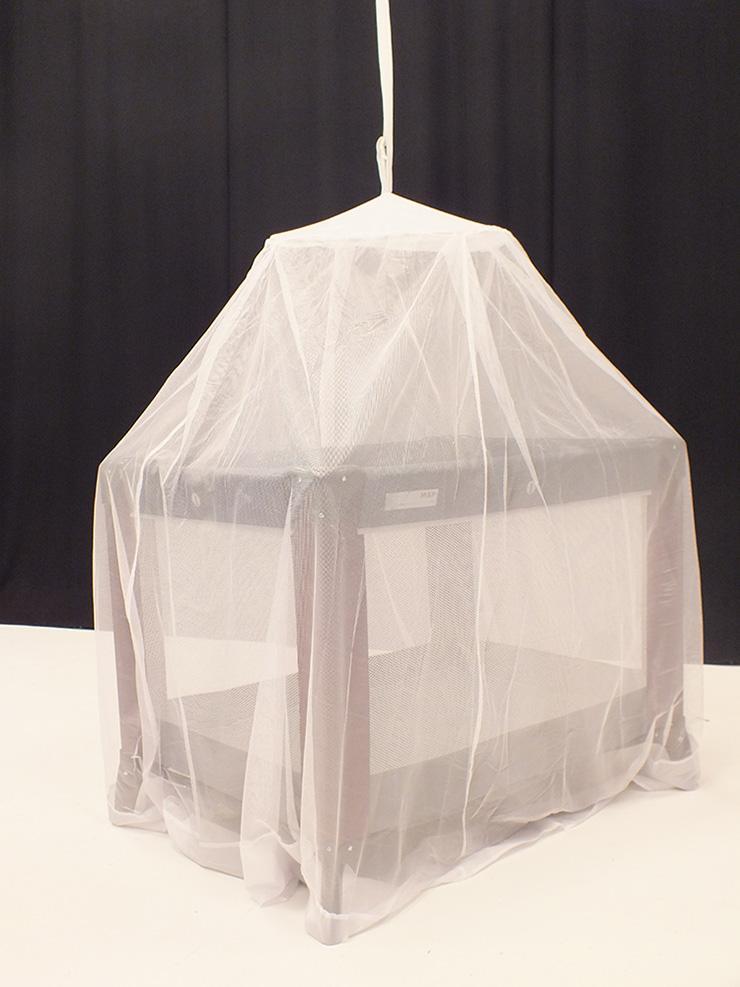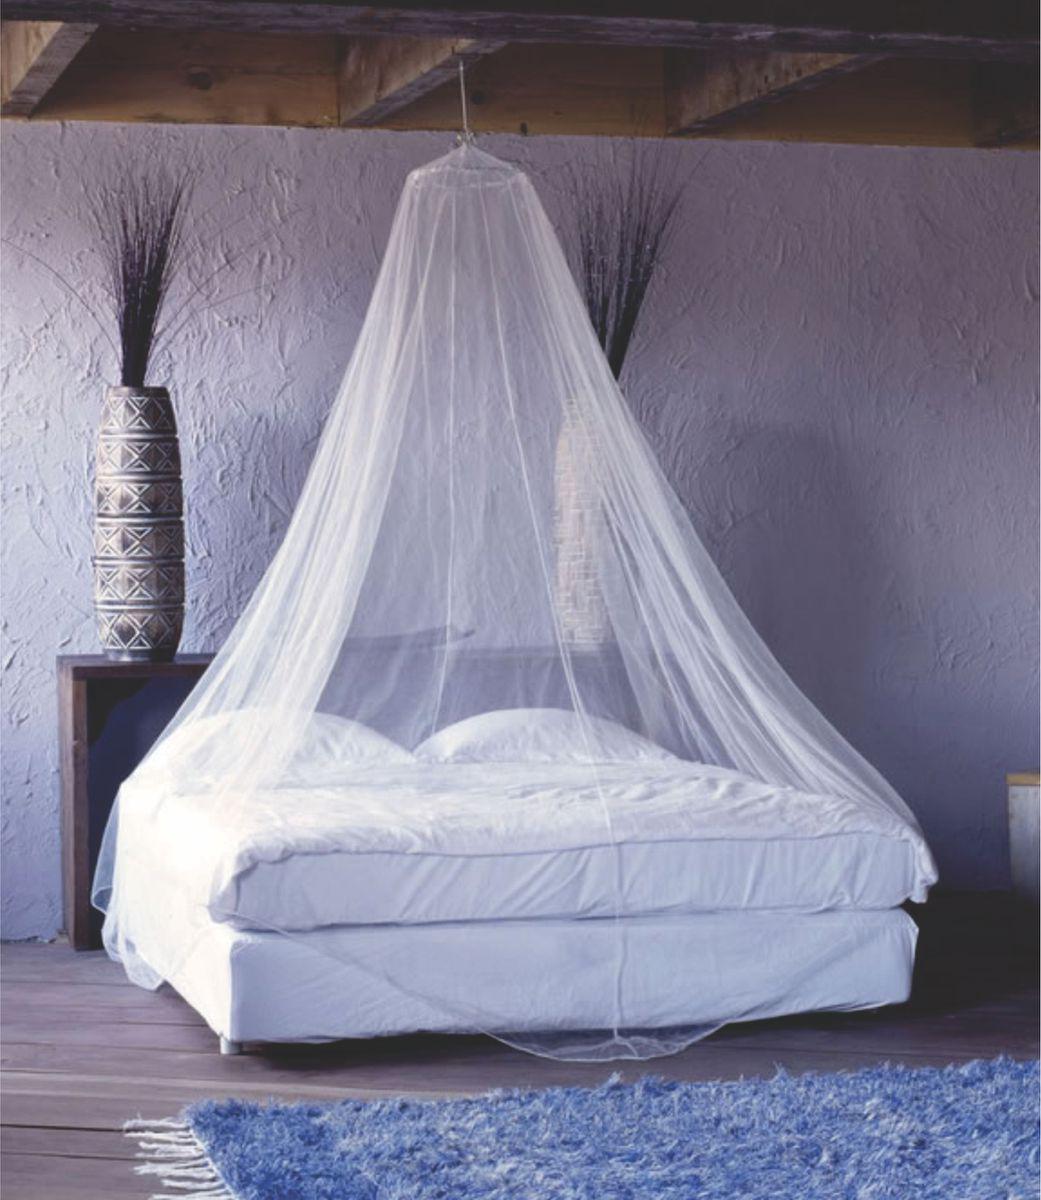The first image is the image on the left, the second image is the image on the right. Evaluate the accuracy of this statement regarding the images: "There are two beds.". Is it true? Answer yes or no. No. 